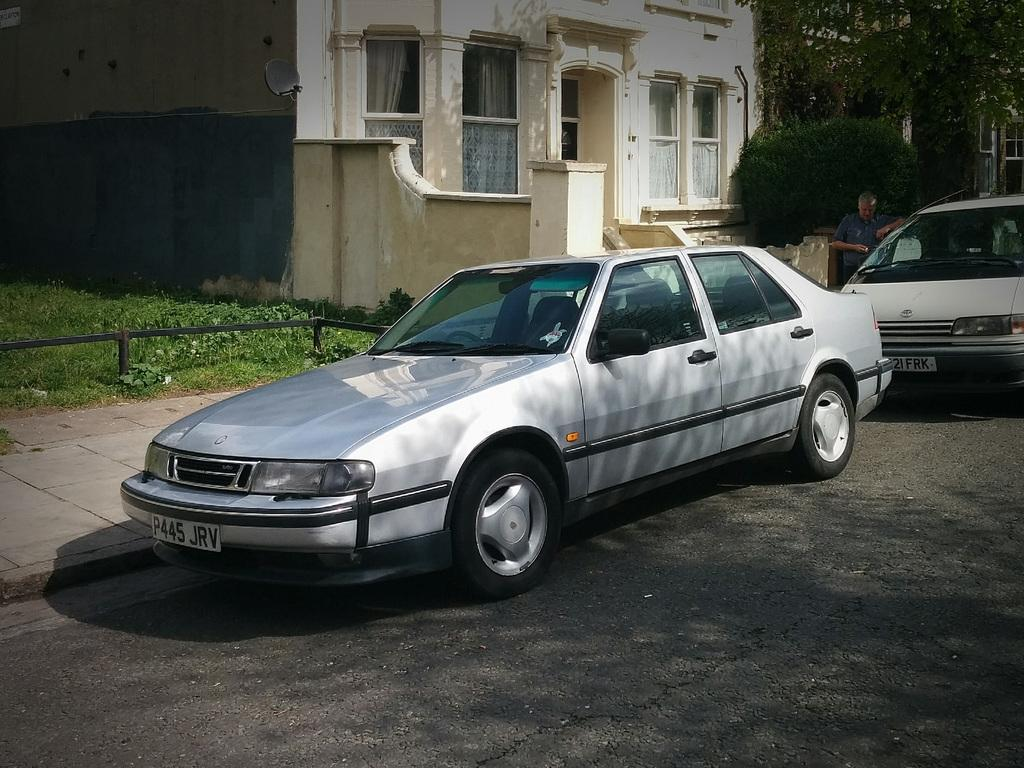What can be seen in the foreground of the image? There are two cars and a person on the road in the foreground of the image. What is visible in the background of the image? There is a building, a fence, grass, windows, and trees visible in the background of the image. Can you describe the time of day when the image was taken? The image was taken during the day. What is the title of the book the person is reading in the image? There is no book or person reading in the image. What is the price of the coil visible in the image? There is no coil present in the image. 